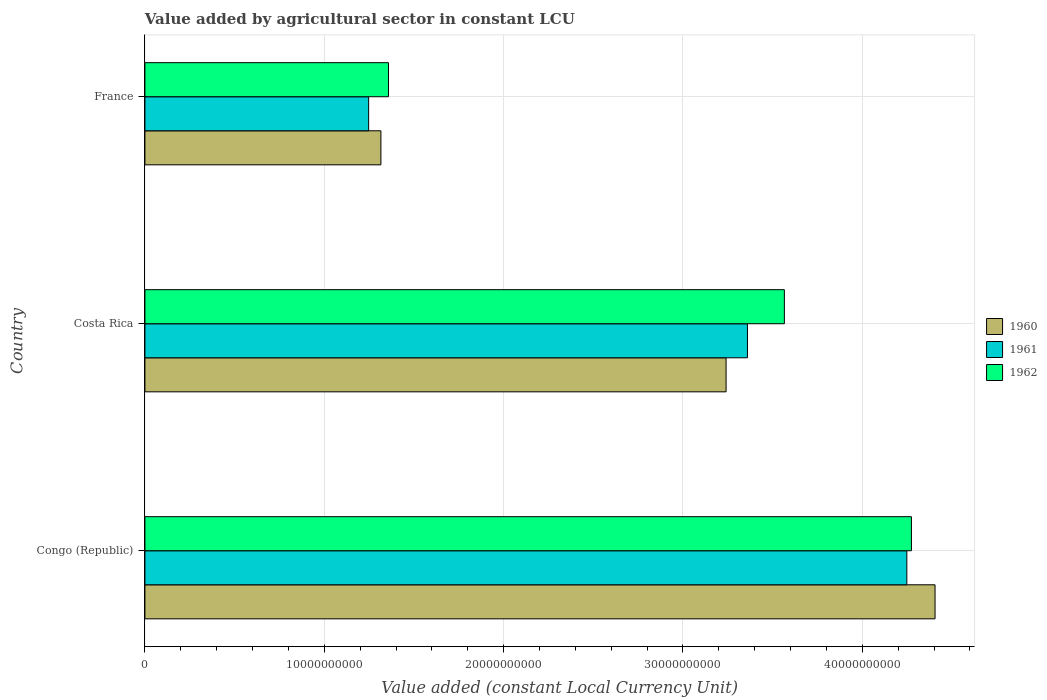How many groups of bars are there?
Your response must be concise. 3. Are the number of bars on each tick of the Y-axis equal?
Provide a short and direct response. Yes. What is the label of the 3rd group of bars from the top?
Provide a succinct answer. Congo (Republic). What is the value added by agricultural sector in 1962 in France?
Offer a very short reply. 1.36e+1. Across all countries, what is the maximum value added by agricultural sector in 1962?
Your response must be concise. 4.27e+1. Across all countries, what is the minimum value added by agricultural sector in 1961?
Provide a short and direct response. 1.25e+1. In which country was the value added by agricultural sector in 1962 maximum?
Offer a terse response. Congo (Republic). In which country was the value added by agricultural sector in 1960 minimum?
Provide a succinct answer. France. What is the total value added by agricultural sector in 1961 in the graph?
Offer a very short reply. 8.86e+1. What is the difference between the value added by agricultural sector in 1961 in Congo (Republic) and that in France?
Ensure brevity in your answer.  3.00e+1. What is the difference between the value added by agricultural sector in 1961 in Costa Rica and the value added by agricultural sector in 1962 in France?
Give a very brief answer. 2.00e+1. What is the average value added by agricultural sector in 1960 per country?
Provide a short and direct response. 2.99e+1. What is the difference between the value added by agricultural sector in 1961 and value added by agricultural sector in 1960 in France?
Ensure brevity in your answer.  -6.84e+08. In how many countries, is the value added by agricultural sector in 1961 greater than 16000000000 LCU?
Your answer should be compact. 2. What is the ratio of the value added by agricultural sector in 1962 in Congo (Republic) to that in Costa Rica?
Make the answer very short. 1.2. Is the value added by agricultural sector in 1960 in Congo (Republic) less than that in Costa Rica?
Give a very brief answer. No. Is the difference between the value added by agricultural sector in 1961 in Congo (Republic) and France greater than the difference between the value added by agricultural sector in 1960 in Congo (Republic) and France?
Offer a terse response. No. What is the difference between the highest and the second highest value added by agricultural sector in 1961?
Your answer should be very brief. 8.89e+09. What is the difference between the highest and the lowest value added by agricultural sector in 1961?
Your answer should be compact. 3.00e+1. Is the sum of the value added by agricultural sector in 1961 in Congo (Republic) and France greater than the maximum value added by agricultural sector in 1962 across all countries?
Keep it short and to the point. Yes. What does the 3rd bar from the top in France represents?
Give a very brief answer. 1960. What does the 2nd bar from the bottom in Congo (Republic) represents?
Provide a succinct answer. 1961. Is it the case that in every country, the sum of the value added by agricultural sector in 1961 and value added by agricultural sector in 1962 is greater than the value added by agricultural sector in 1960?
Make the answer very short. Yes. Are all the bars in the graph horizontal?
Offer a very short reply. Yes. How many countries are there in the graph?
Your response must be concise. 3. What is the difference between two consecutive major ticks on the X-axis?
Offer a terse response. 1.00e+1. Does the graph contain any zero values?
Your answer should be compact. No. Where does the legend appear in the graph?
Give a very brief answer. Center right. How many legend labels are there?
Offer a terse response. 3. What is the title of the graph?
Your answer should be compact. Value added by agricultural sector in constant LCU. Does "1990" appear as one of the legend labels in the graph?
Give a very brief answer. No. What is the label or title of the X-axis?
Provide a succinct answer. Value added (constant Local Currency Unit). What is the label or title of the Y-axis?
Give a very brief answer. Country. What is the Value added (constant Local Currency Unit) of 1960 in Congo (Republic)?
Your answer should be compact. 4.41e+1. What is the Value added (constant Local Currency Unit) in 1961 in Congo (Republic)?
Keep it short and to the point. 4.25e+1. What is the Value added (constant Local Currency Unit) in 1962 in Congo (Republic)?
Your answer should be compact. 4.27e+1. What is the Value added (constant Local Currency Unit) in 1960 in Costa Rica?
Offer a terse response. 3.24e+1. What is the Value added (constant Local Currency Unit) of 1961 in Costa Rica?
Provide a short and direct response. 3.36e+1. What is the Value added (constant Local Currency Unit) in 1962 in Costa Rica?
Offer a very short reply. 3.57e+1. What is the Value added (constant Local Currency Unit) in 1960 in France?
Make the answer very short. 1.32e+1. What is the Value added (constant Local Currency Unit) in 1961 in France?
Make the answer very short. 1.25e+1. What is the Value added (constant Local Currency Unit) of 1962 in France?
Make the answer very short. 1.36e+1. Across all countries, what is the maximum Value added (constant Local Currency Unit) in 1960?
Give a very brief answer. 4.41e+1. Across all countries, what is the maximum Value added (constant Local Currency Unit) in 1961?
Your answer should be very brief. 4.25e+1. Across all countries, what is the maximum Value added (constant Local Currency Unit) in 1962?
Offer a terse response. 4.27e+1. Across all countries, what is the minimum Value added (constant Local Currency Unit) of 1960?
Your answer should be very brief. 1.32e+1. Across all countries, what is the minimum Value added (constant Local Currency Unit) in 1961?
Offer a very short reply. 1.25e+1. Across all countries, what is the minimum Value added (constant Local Currency Unit) of 1962?
Offer a terse response. 1.36e+1. What is the total Value added (constant Local Currency Unit) in 1960 in the graph?
Offer a very short reply. 8.96e+1. What is the total Value added (constant Local Currency Unit) of 1961 in the graph?
Give a very brief answer. 8.86e+1. What is the total Value added (constant Local Currency Unit) in 1962 in the graph?
Offer a very short reply. 9.20e+1. What is the difference between the Value added (constant Local Currency Unit) of 1960 in Congo (Republic) and that in Costa Rica?
Your response must be concise. 1.17e+1. What is the difference between the Value added (constant Local Currency Unit) of 1961 in Congo (Republic) and that in Costa Rica?
Offer a very short reply. 8.89e+09. What is the difference between the Value added (constant Local Currency Unit) in 1962 in Congo (Republic) and that in Costa Rica?
Ensure brevity in your answer.  7.08e+09. What is the difference between the Value added (constant Local Currency Unit) in 1960 in Congo (Republic) and that in France?
Keep it short and to the point. 3.09e+1. What is the difference between the Value added (constant Local Currency Unit) in 1961 in Congo (Republic) and that in France?
Provide a succinct answer. 3.00e+1. What is the difference between the Value added (constant Local Currency Unit) in 1962 in Congo (Republic) and that in France?
Provide a succinct answer. 2.92e+1. What is the difference between the Value added (constant Local Currency Unit) in 1960 in Costa Rica and that in France?
Your response must be concise. 1.92e+1. What is the difference between the Value added (constant Local Currency Unit) of 1961 in Costa Rica and that in France?
Your answer should be compact. 2.11e+1. What is the difference between the Value added (constant Local Currency Unit) in 1962 in Costa Rica and that in France?
Ensure brevity in your answer.  2.21e+1. What is the difference between the Value added (constant Local Currency Unit) in 1960 in Congo (Republic) and the Value added (constant Local Currency Unit) in 1961 in Costa Rica?
Your answer should be very brief. 1.05e+1. What is the difference between the Value added (constant Local Currency Unit) of 1960 in Congo (Republic) and the Value added (constant Local Currency Unit) of 1962 in Costa Rica?
Your answer should be very brief. 8.40e+09. What is the difference between the Value added (constant Local Currency Unit) in 1961 in Congo (Republic) and the Value added (constant Local Currency Unit) in 1962 in Costa Rica?
Offer a very short reply. 6.83e+09. What is the difference between the Value added (constant Local Currency Unit) in 1960 in Congo (Republic) and the Value added (constant Local Currency Unit) in 1961 in France?
Your answer should be compact. 3.16e+1. What is the difference between the Value added (constant Local Currency Unit) of 1960 in Congo (Republic) and the Value added (constant Local Currency Unit) of 1962 in France?
Provide a succinct answer. 3.05e+1. What is the difference between the Value added (constant Local Currency Unit) of 1961 in Congo (Republic) and the Value added (constant Local Currency Unit) of 1962 in France?
Your answer should be compact. 2.89e+1. What is the difference between the Value added (constant Local Currency Unit) of 1960 in Costa Rica and the Value added (constant Local Currency Unit) of 1961 in France?
Give a very brief answer. 1.99e+1. What is the difference between the Value added (constant Local Currency Unit) of 1960 in Costa Rica and the Value added (constant Local Currency Unit) of 1962 in France?
Your answer should be compact. 1.88e+1. What is the difference between the Value added (constant Local Currency Unit) of 1961 in Costa Rica and the Value added (constant Local Currency Unit) of 1962 in France?
Offer a very short reply. 2.00e+1. What is the average Value added (constant Local Currency Unit) in 1960 per country?
Provide a succinct answer. 2.99e+1. What is the average Value added (constant Local Currency Unit) in 1961 per country?
Offer a very short reply. 2.95e+1. What is the average Value added (constant Local Currency Unit) of 1962 per country?
Make the answer very short. 3.07e+1. What is the difference between the Value added (constant Local Currency Unit) in 1960 and Value added (constant Local Currency Unit) in 1961 in Congo (Republic)?
Provide a succinct answer. 1.57e+09. What is the difference between the Value added (constant Local Currency Unit) in 1960 and Value added (constant Local Currency Unit) in 1962 in Congo (Republic)?
Keep it short and to the point. 1.32e+09. What is the difference between the Value added (constant Local Currency Unit) of 1961 and Value added (constant Local Currency Unit) of 1962 in Congo (Republic)?
Make the answer very short. -2.56e+08. What is the difference between the Value added (constant Local Currency Unit) in 1960 and Value added (constant Local Currency Unit) in 1961 in Costa Rica?
Offer a terse response. -1.19e+09. What is the difference between the Value added (constant Local Currency Unit) in 1960 and Value added (constant Local Currency Unit) in 1962 in Costa Rica?
Provide a short and direct response. -3.25e+09. What is the difference between the Value added (constant Local Currency Unit) of 1961 and Value added (constant Local Currency Unit) of 1962 in Costa Rica?
Make the answer very short. -2.06e+09. What is the difference between the Value added (constant Local Currency Unit) in 1960 and Value added (constant Local Currency Unit) in 1961 in France?
Your answer should be very brief. 6.84e+08. What is the difference between the Value added (constant Local Currency Unit) of 1960 and Value added (constant Local Currency Unit) of 1962 in France?
Provide a short and direct response. -4.23e+08. What is the difference between the Value added (constant Local Currency Unit) in 1961 and Value added (constant Local Currency Unit) in 1962 in France?
Make the answer very short. -1.11e+09. What is the ratio of the Value added (constant Local Currency Unit) of 1960 in Congo (Republic) to that in Costa Rica?
Offer a very short reply. 1.36. What is the ratio of the Value added (constant Local Currency Unit) in 1961 in Congo (Republic) to that in Costa Rica?
Your answer should be very brief. 1.26. What is the ratio of the Value added (constant Local Currency Unit) of 1962 in Congo (Republic) to that in Costa Rica?
Offer a very short reply. 1.2. What is the ratio of the Value added (constant Local Currency Unit) in 1960 in Congo (Republic) to that in France?
Provide a short and direct response. 3.35. What is the ratio of the Value added (constant Local Currency Unit) in 1961 in Congo (Republic) to that in France?
Offer a terse response. 3.41. What is the ratio of the Value added (constant Local Currency Unit) in 1962 in Congo (Republic) to that in France?
Offer a terse response. 3.15. What is the ratio of the Value added (constant Local Currency Unit) in 1960 in Costa Rica to that in France?
Provide a succinct answer. 2.46. What is the ratio of the Value added (constant Local Currency Unit) in 1961 in Costa Rica to that in France?
Your response must be concise. 2.69. What is the ratio of the Value added (constant Local Currency Unit) of 1962 in Costa Rica to that in France?
Keep it short and to the point. 2.63. What is the difference between the highest and the second highest Value added (constant Local Currency Unit) in 1960?
Offer a very short reply. 1.17e+1. What is the difference between the highest and the second highest Value added (constant Local Currency Unit) of 1961?
Give a very brief answer. 8.89e+09. What is the difference between the highest and the second highest Value added (constant Local Currency Unit) of 1962?
Provide a short and direct response. 7.08e+09. What is the difference between the highest and the lowest Value added (constant Local Currency Unit) in 1960?
Your answer should be compact. 3.09e+1. What is the difference between the highest and the lowest Value added (constant Local Currency Unit) in 1961?
Make the answer very short. 3.00e+1. What is the difference between the highest and the lowest Value added (constant Local Currency Unit) in 1962?
Offer a terse response. 2.92e+1. 